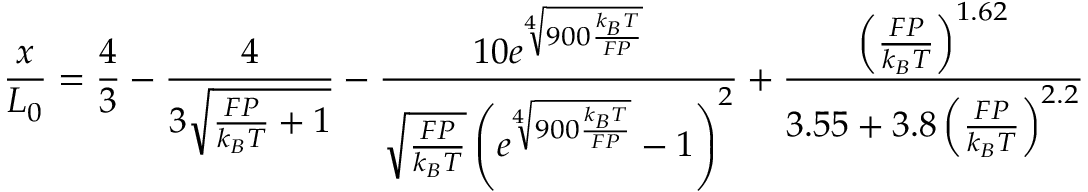<formula> <loc_0><loc_0><loc_500><loc_500>{ \frac { x } { L _ { 0 } } } = { \frac { 4 } { 3 } } - { \frac { 4 } { 3 { \sqrt { { \frac { F P } { k _ { B } T } } + 1 } } } } - { \frac { 1 0 e ^ { \sqrt { [ } { 4 } ] { 9 0 0 { \frac { k _ { B } T } { F P } } } } } { { \sqrt { \frac { F P } { k _ { B } T } } } \left ( e ^ { \sqrt { [ } { 4 } ] { 9 0 0 { \frac { k _ { B } T } { F P } } } } - 1 \right ) ^ { 2 } } } + { \frac { \left ( { \frac { F P } { k _ { B } T } } \right ) ^ { 1 . 6 2 } } { 3 . 5 5 + 3 . 8 \left ( { \frac { F P } { k _ { B } T } } \right ) ^ { 2 . 2 } } }</formula> 